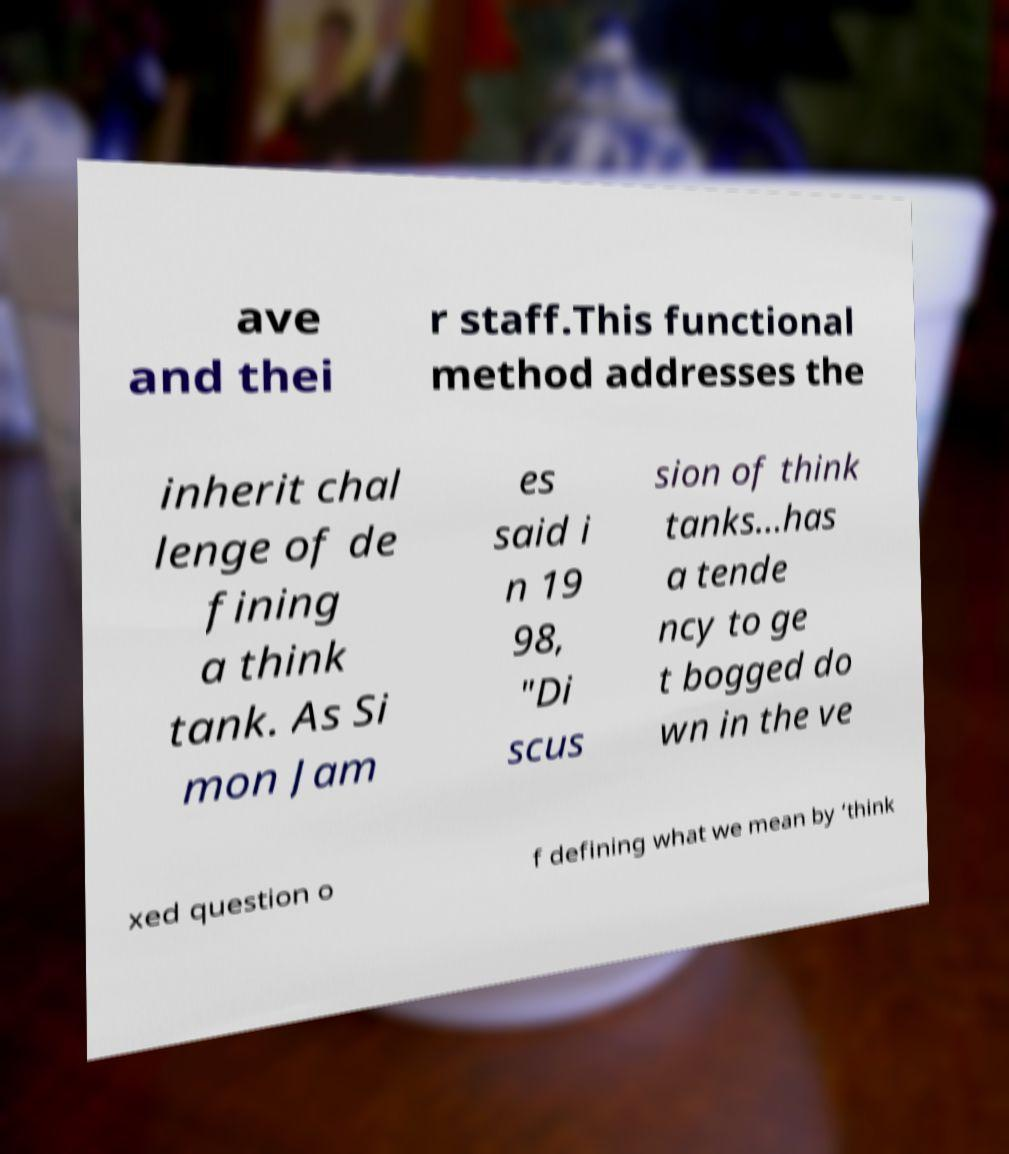What messages or text are displayed in this image? I need them in a readable, typed format. ave and thei r staff.This functional method addresses the inherit chal lenge of de fining a think tank. As Si mon Jam es said i n 19 98, "Di scus sion of think tanks...has a tende ncy to ge t bogged do wn in the ve xed question o f defining what we mean by ‘think 